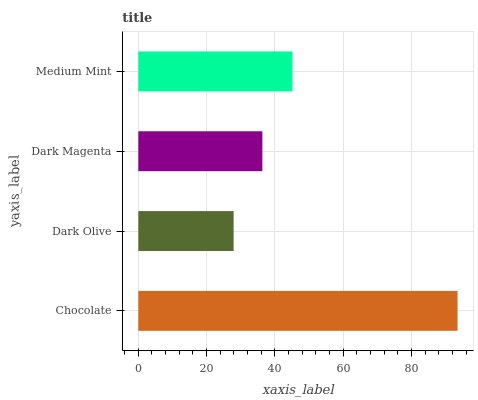Is Dark Olive the minimum?
Answer yes or no. Yes. Is Chocolate the maximum?
Answer yes or no. Yes. Is Dark Magenta the minimum?
Answer yes or no. No. Is Dark Magenta the maximum?
Answer yes or no. No. Is Dark Magenta greater than Dark Olive?
Answer yes or no. Yes. Is Dark Olive less than Dark Magenta?
Answer yes or no. Yes. Is Dark Olive greater than Dark Magenta?
Answer yes or no. No. Is Dark Magenta less than Dark Olive?
Answer yes or no. No. Is Medium Mint the high median?
Answer yes or no. Yes. Is Dark Magenta the low median?
Answer yes or no. Yes. Is Dark Olive the high median?
Answer yes or no. No. Is Chocolate the low median?
Answer yes or no. No. 